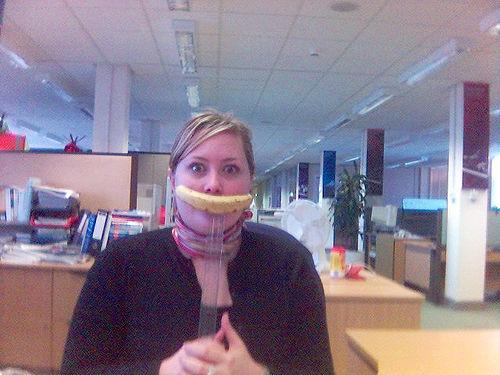Does the banana still have the peel?
Concise answer only. Yes. What type of setting is this?
Short answer required. Office. Why does the woman have the banana in her mouth?
Quick response, please. Yes. 